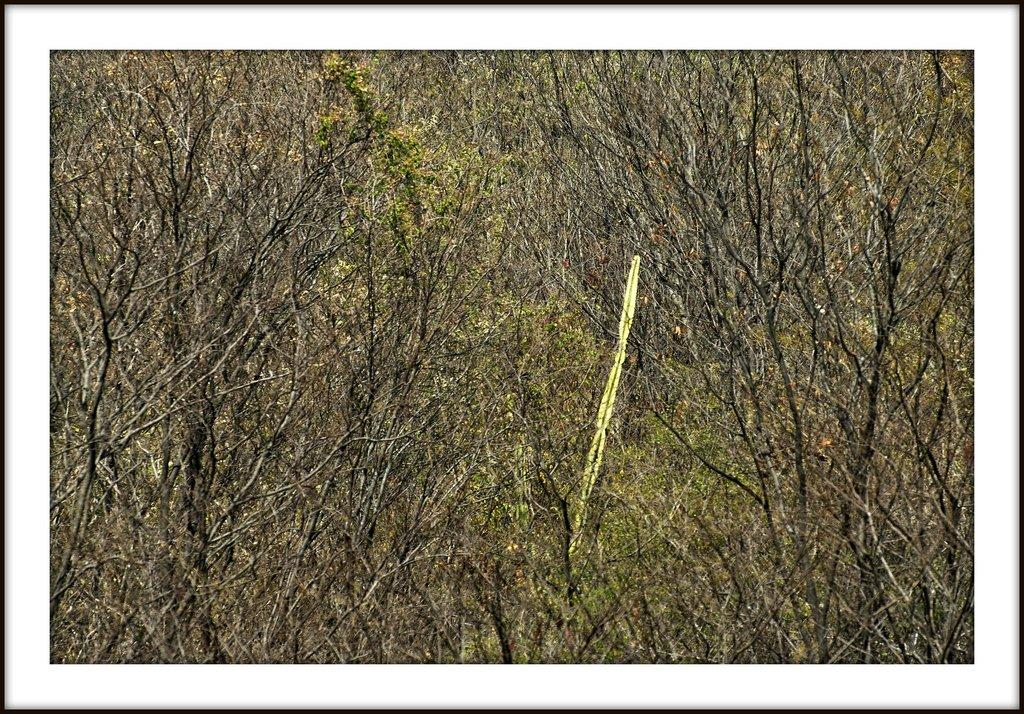What type of trees are visible in the image? There are bare trees in the image. What type of veil is draped over the oven in the image? There is no veil or oven present in the image; it only features bare trees. 